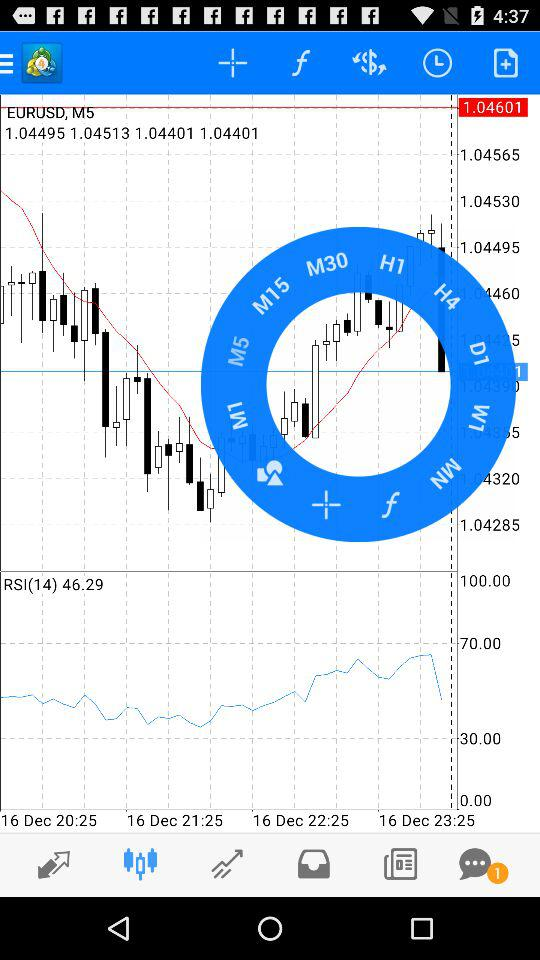How many time intervals are displayed?
Answer the question using a single word or phrase. 4 